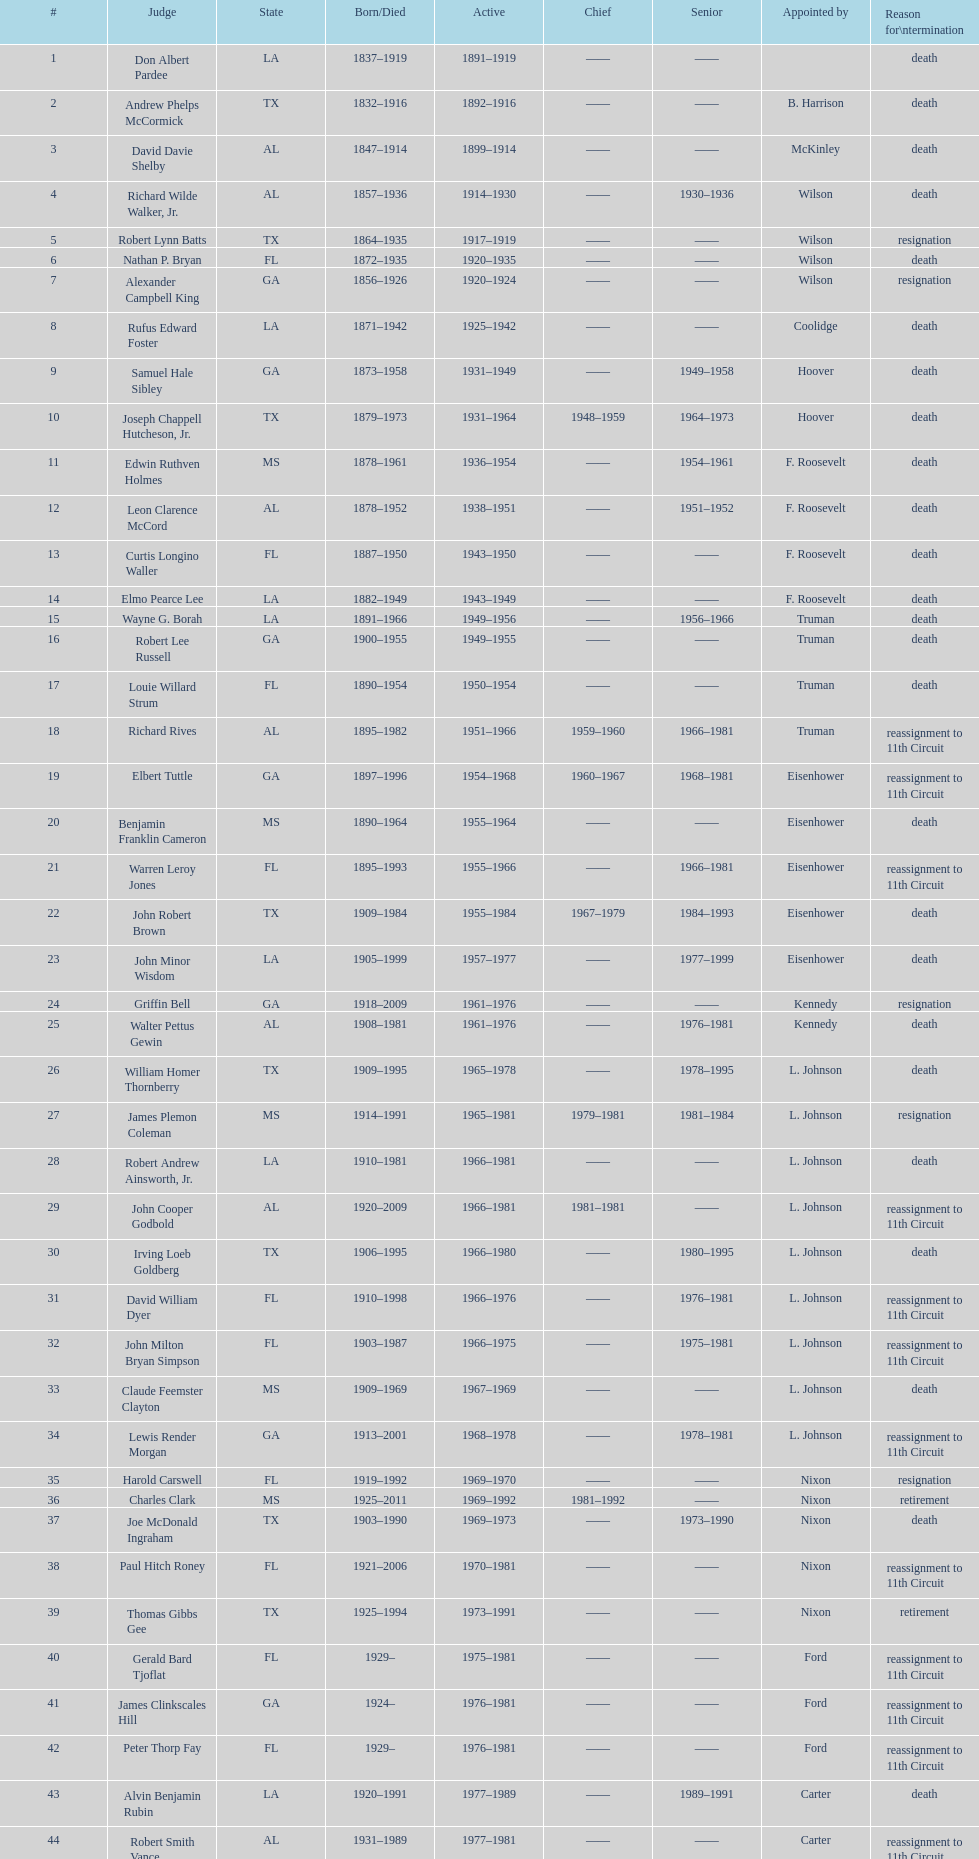After alexander campbell king, which judge resigned next? Griffin Bell. 